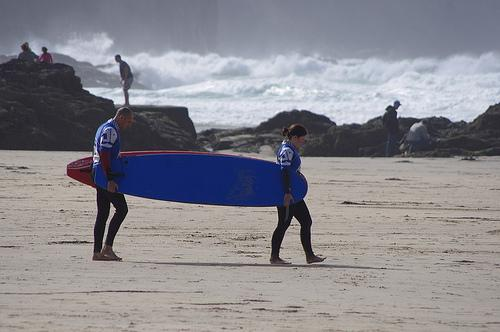Compose a short account of the image, mentioning the attire and accessories of the individuals. A man wearing a hat and other individuals in a mix of blue, white, and pink clothes carry surfboards across a beach, leaving footprints in the sand. Briefly elaborate on the appearance of the individuals and their surroundings in the image. Men and women of various ages, dressed in different colors, carry surfboards while strolling along a beach with distinct footprints, crashing waves, and rocks. Enumerate the primary activities being carried out and the main objects present in the image. Carrying surfboards, walking on a sandy beach with footprints, and observing waves crashing and rocks nearby are the central activities in the image. Craft a concise description of the image, highlighting the color palette. People in blue and white clothes carry colorful surfboards on a brown, sandy beach with white waves crashing in the background. In one sentence, describe the essence of this image and the key components. People dressed in variety of colors carry surfboards on a sandy beach with noticeable footprints and tracks, and wave-rocks in the background. Elaborate on the major activity happening in the picture and the main elements involved. People are walking barefoot on a sandy beach carrying blue and red surfboards, while footprints and tracks can be seen all over the sand. Depict the relationships between the people in the picture and what they are doing. A man walking with a boy, a woman in front, and other people carry surfboards together, with two individuals holding one board, as they make their way across the beach. Provide a brief narration of the key constituents in the image. A group of people, clad in matching outfits, is carrying surfboards along the sandy shore, leaving footprints as they pass by a crashing wave. Paint a picture in words of the image while emphasizing on the activities taking place. Barefoot people carrying colorful surfboards traverse across a sandy beach, leaving footprints and tracks, while waves crash and rocks surround them. Describe the setting of the image and the actions being performed by the subjects. On a sandy beach with footprints and ocean waves, people are walking, carrying surfboards, with a man donning a hat standing atop a huge rock. 